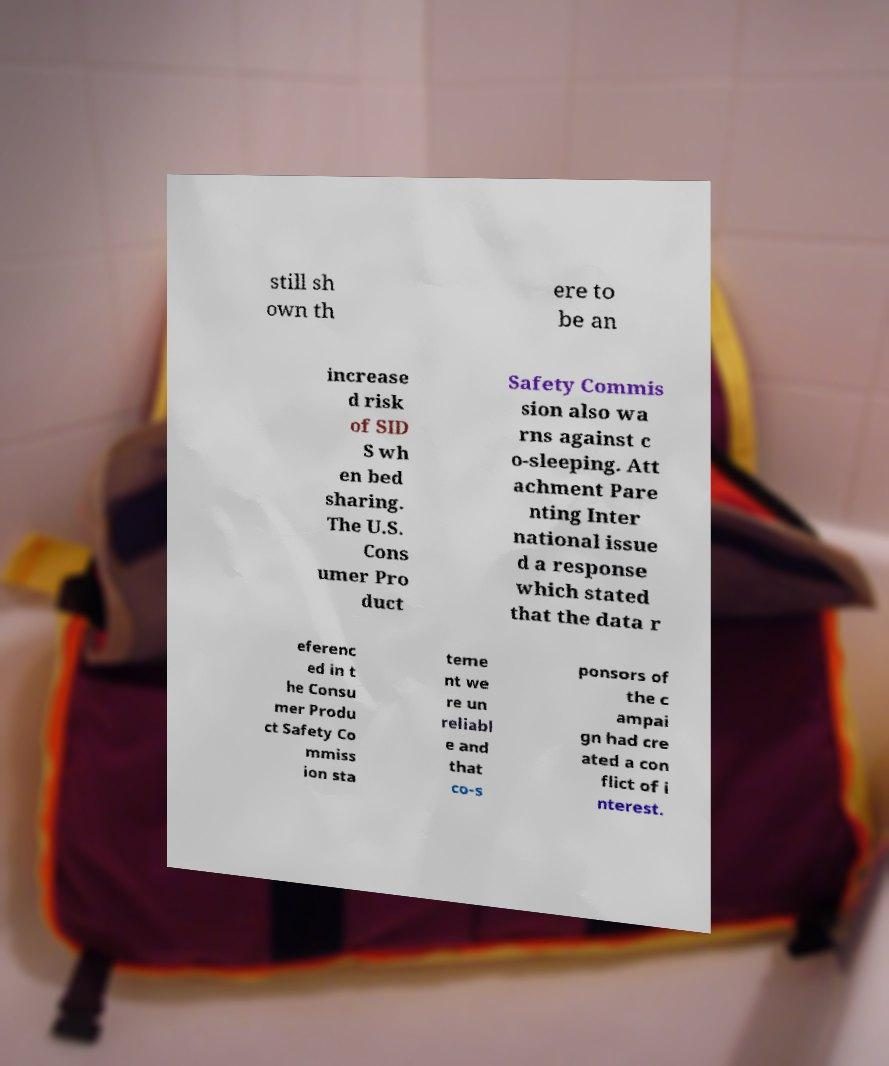There's text embedded in this image that I need extracted. Can you transcribe it verbatim? still sh own th ere to be an increase d risk of SID S wh en bed sharing. The U.S. Cons umer Pro duct Safety Commis sion also wa rns against c o-sleeping. Att achment Pare nting Inter national issue d a response which stated that the data r eferenc ed in t he Consu mer Produ ct Safety Co mmiss ion sta teme nt we re un reliabl e and that co-s ponsors of the c ampai gn had cre ated a con flict of i nterest. 